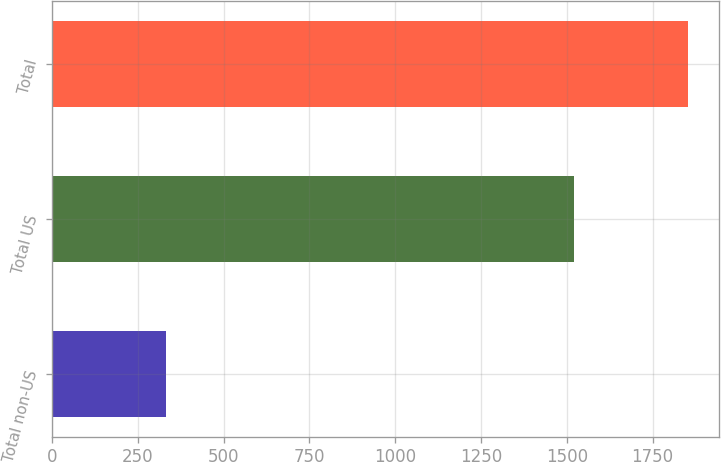<chart> <loc_0><loc_0><loc_500><loc_500><bar_chart><fcel>Total non-US<fcel>Total US<fcel>Total<nl><fcel>332<fcel>1520<fcel>1852<nl></chart> 